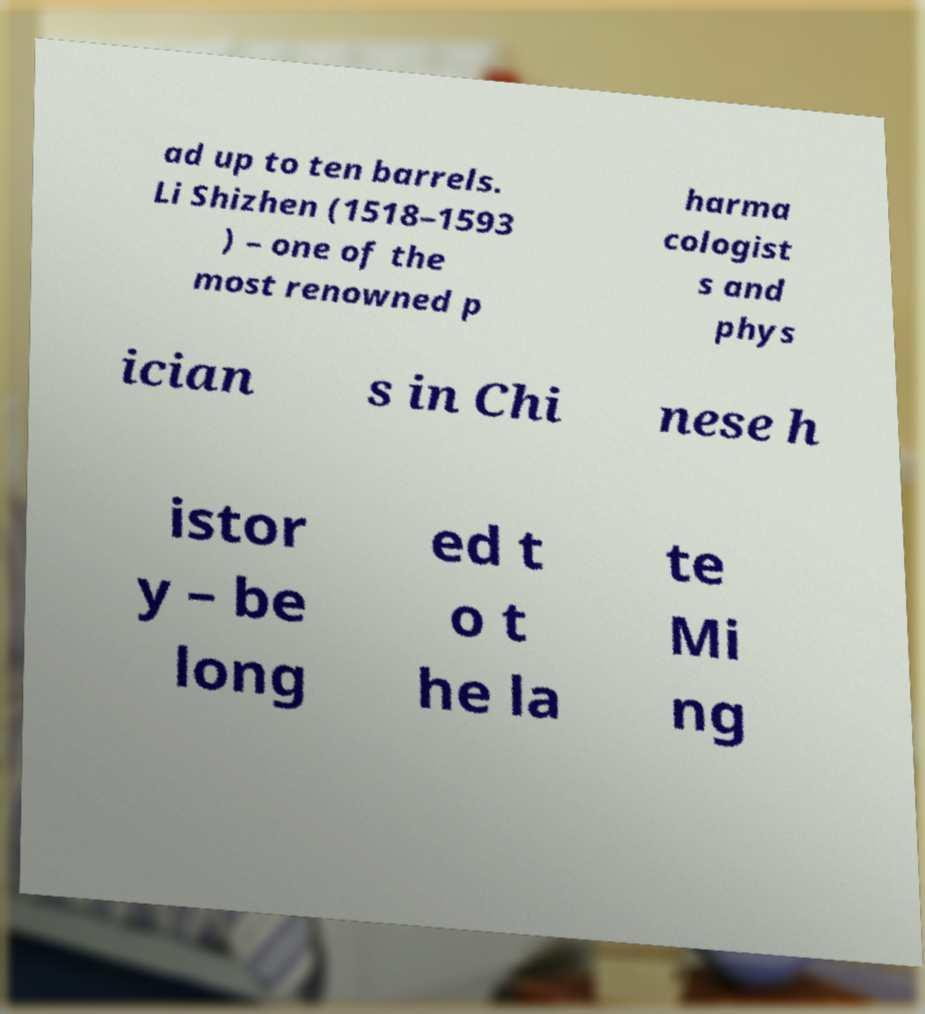I need the written content from this picture converted into text. Can you do that? ad up to ten barrels. Li Shizhen (1518–1593 ) – one of the most renowned p harma cologist s and phys ician s in Chi nese h istor y – be long ed t o t he la te Mi ng 